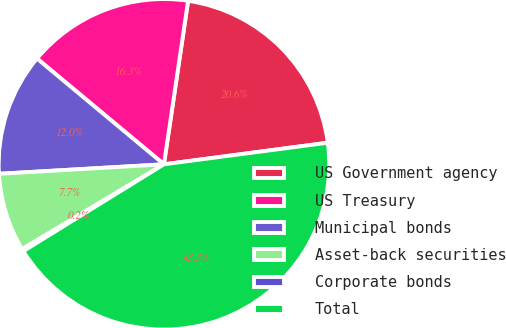Convert chart to OTSL. <chart><loc_0><loc_0><loc_500><loc_500><pie_chart><fcel>US Government agency<fcel>US Treasury<fcel>Municipal bonds<fcel>Asset-back securities<fcel>Corporate bonds<fcel>Total<nl><fcel>20.58%<fcel>16.28%<fcel>11.97%<fcel>7.66%<fcel>0.23%<fcel>43.28%<nl></chart> 